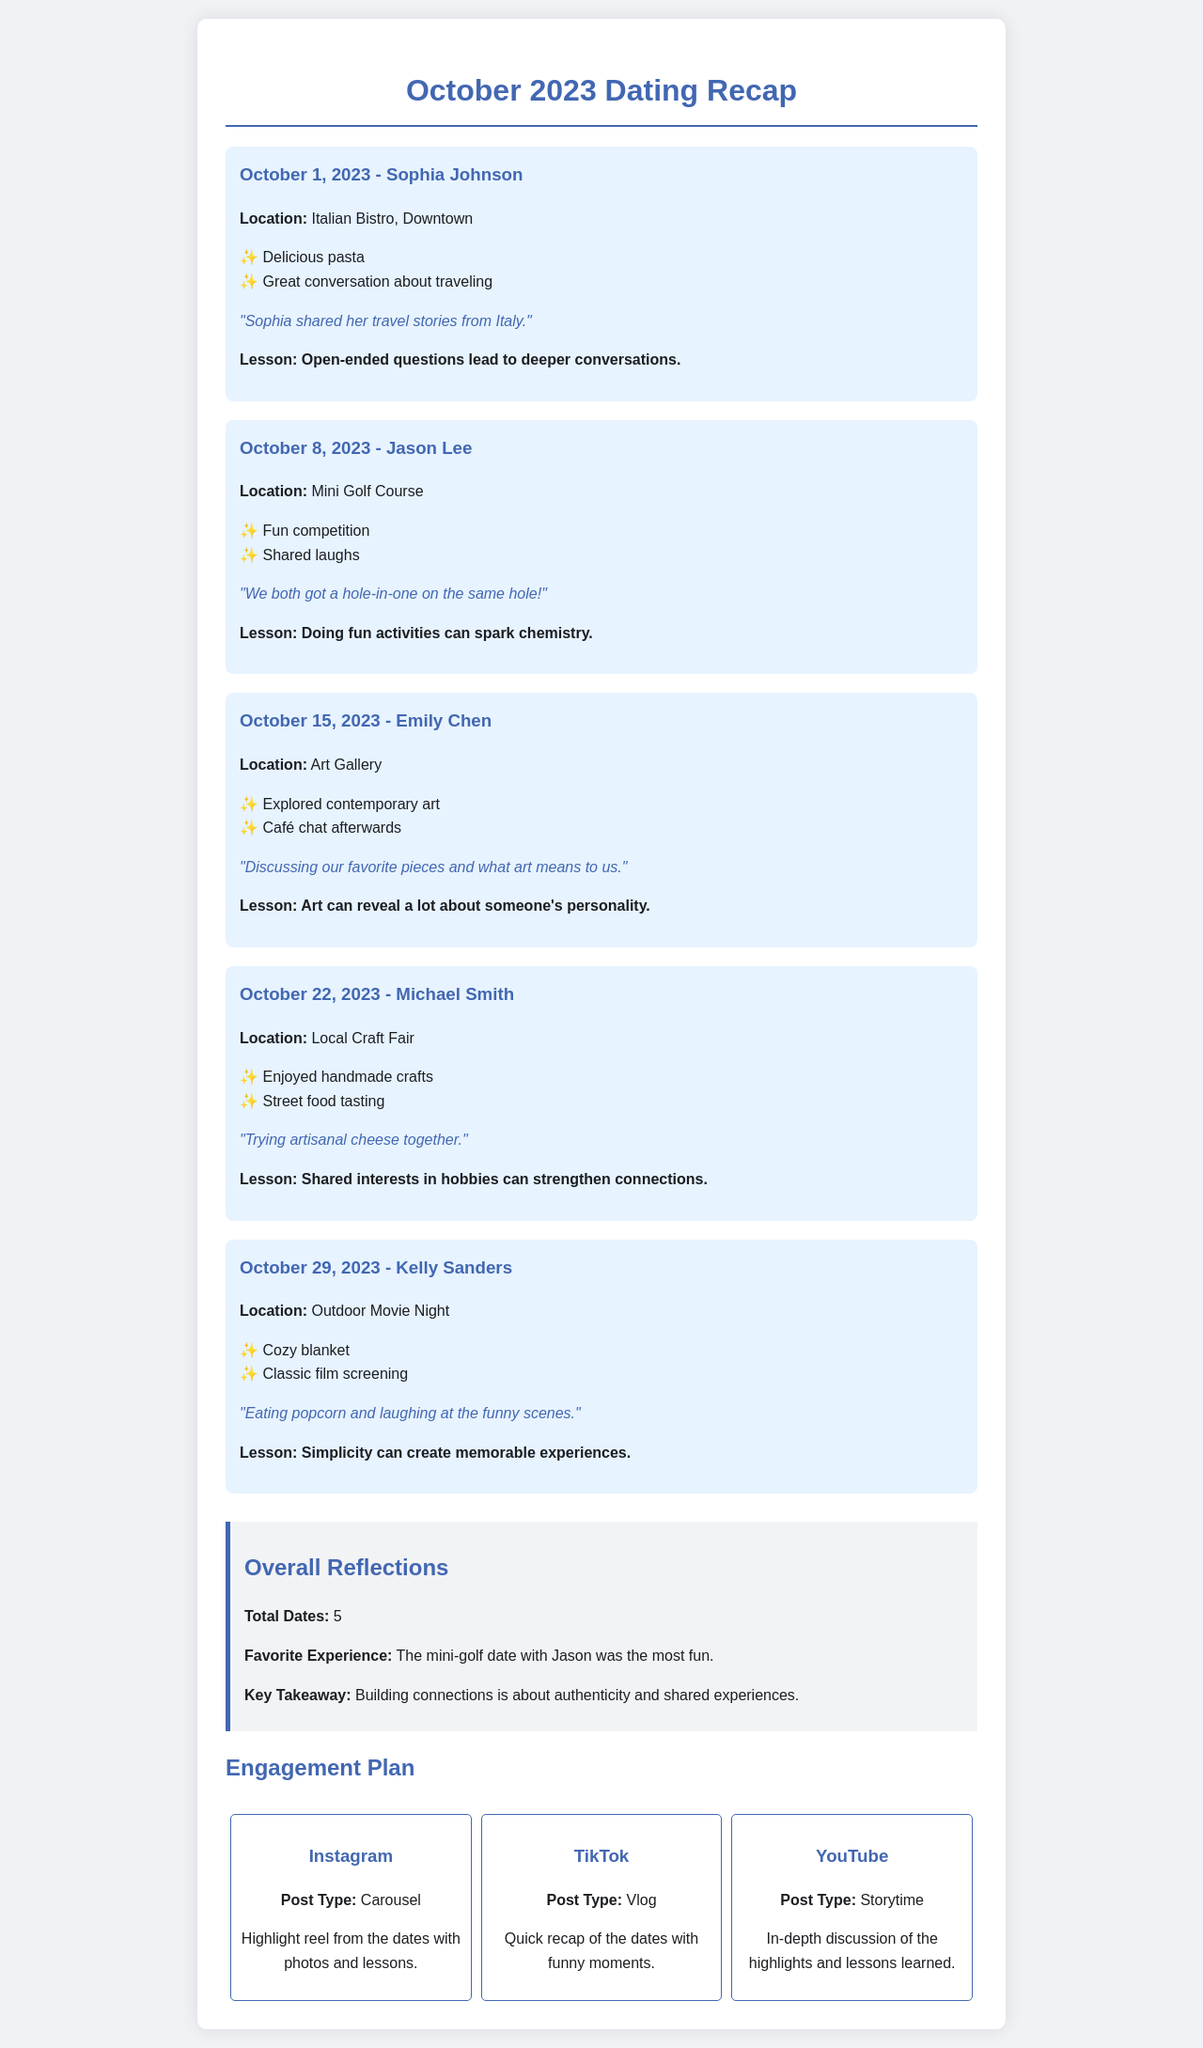What was the date of the first date? The first date listed in the document is on October 1, 2023.
Answer: October 1, 2023 How many dates were summarized in the recap? The document provides a summary of a total of 5 dates.
Answer: 5 What is the favorite moment from the date with Sophia? The favorite moment from the date with Sophia is about her travel stories from Italy.
Answer: "Sophia shared her travel stories from Italy." What lesson was learned from the mini-golf date? The lesson learned from the mini-golf date emphasizes that fun activities can spark chemistry.
Answer: Doing fun activities can spark chemistry Which date involved trying artisanal cheese? The date that involved trying artisanal cheese was with Michael Smith.
Answer: Michael Smith What was the favorite experience highlighted in the overall reflections? The favorite experience highlighted was the mini-golf date with Jason.
Answer: The mini-golf date with Jason What location did the date with Kelly Sanders take place? The location for the date with Kelly Sanders was an outdoor movie night.
Answer: Outdoor Movie Night What platform will feature a highlight reel from the dates? The platform featuring a highlight reel from the dates is Instagram.
Answer: Instagram What was discussed with Emily Chen after exploring contemporary art? The discussion after exploring contemporary art was about their favorite pieces and what art means to them.
Answer: Discussing our favorite pieces and what art means to us 